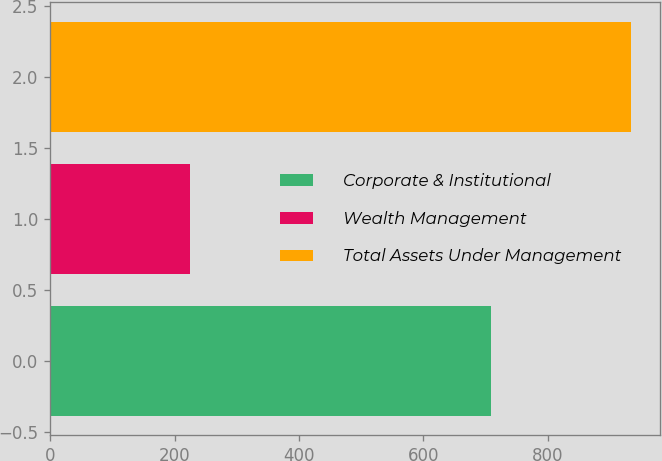<chart> <loc_0><loc_0><loc_500><loc_500><bar_chart><fcel>Corporate & Institutional<fcel>Wealth Management<fcel>Total Assets Under Management<nl><fcel>709.6<fcel>224.5<fcel>934.1<nl></chart> 